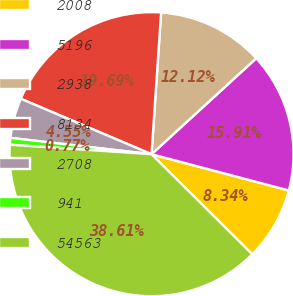<chart> <loc_0><loc_0><loc_500><loc_500><pie_chart><fcel>2008<fcel>5196<fcel>2938<fcel>8134<fcel>2708<fcel>941<fcel>54563<nl><fcel>8.34%<fcel>15.91%<fcel>12.12%<fcel>19.69%<fcel>4.55%<fcel>0.77%<fcel>38.61%<nl></chart> 